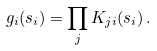Convert formula to latex. <formula><loc_0><loc_0><loc_500><loc_500>g _ { i } ( s _ { i } ) = \prod _ { j } K _ { j i } ( s _ { i } ) \, .</formula> 